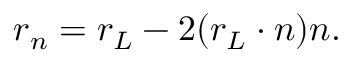Convert formula to latex. <formula><loc_0><loc_0><loc_500><loc_500>r _ { n } = r _ { L } - 2 ( r _ { L } \cdot n ) n .</formula> 